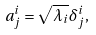<formula> <loc_0><loc_0><loc_500><loc_500>a ^ { i } _ { j } = \sqrt { \lambda _ { i } } \delta ^ { i } _ { j } ,</formula> 